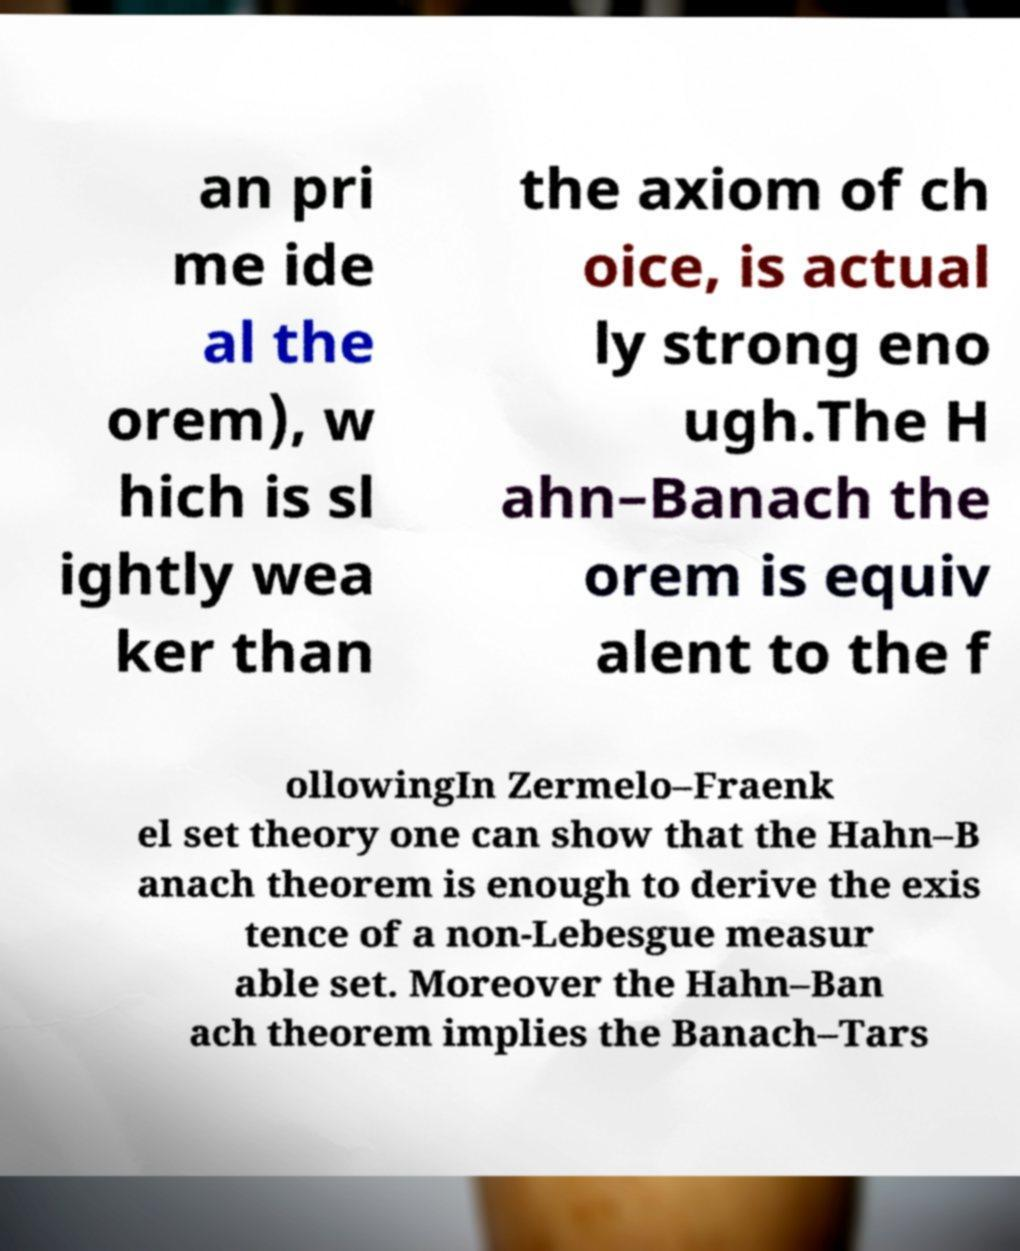I need the written content from this picture converted into text. Can you do that? an pri me ide al the orem), w hich is sl ightly wea ker than the axiom of ch oice, is actual ly strong eno ugh.The H ahn–Banach the orem is equiv alent to the f ollowingIn Zermelo–Fraenk el set theory one can show that the Hahn–B anach theorem is enough to derive the exis tence of a non-Lebesgue measur able set. Moreover the Hahn–Ban ach theorem implies the Banach–Tars 